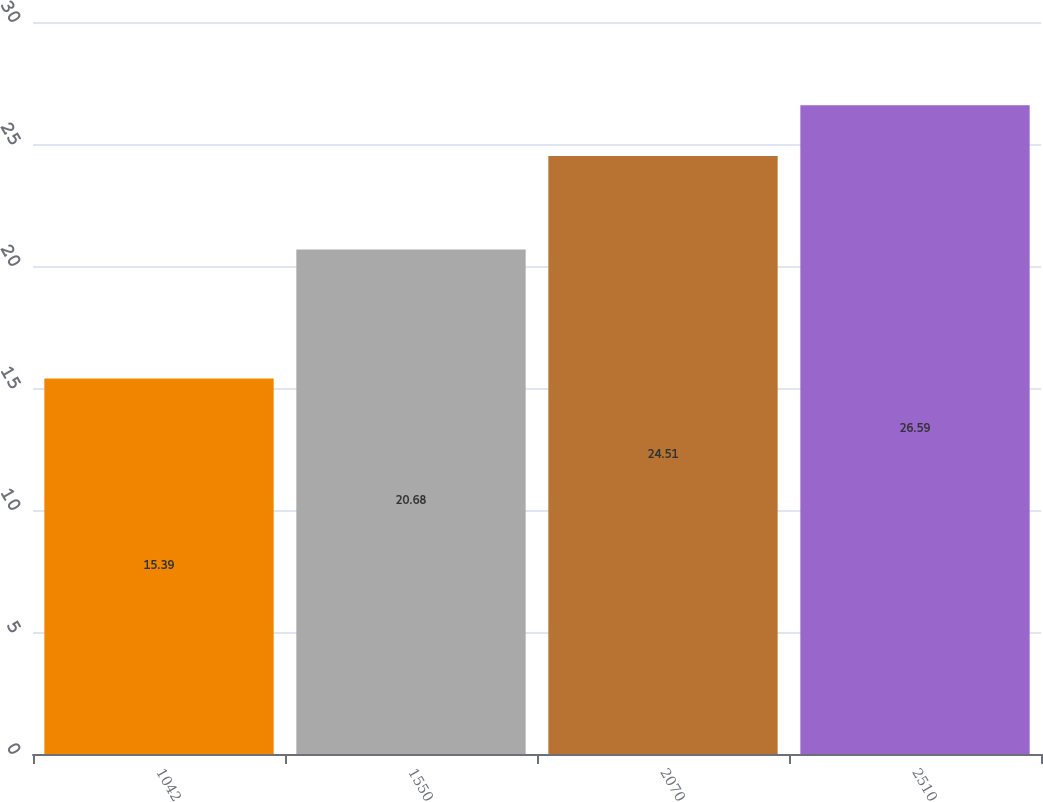Convert chart to OTSL. <chart><loc_0><loc_0><loc_500><loc_500><bar_chart><fcel>1042<fcel>1550<fcel>2070<fcel>2510<nl><fcel>15.39<fcel>20.68<fcel>24.51<fcel>26.59<nl></chart> 